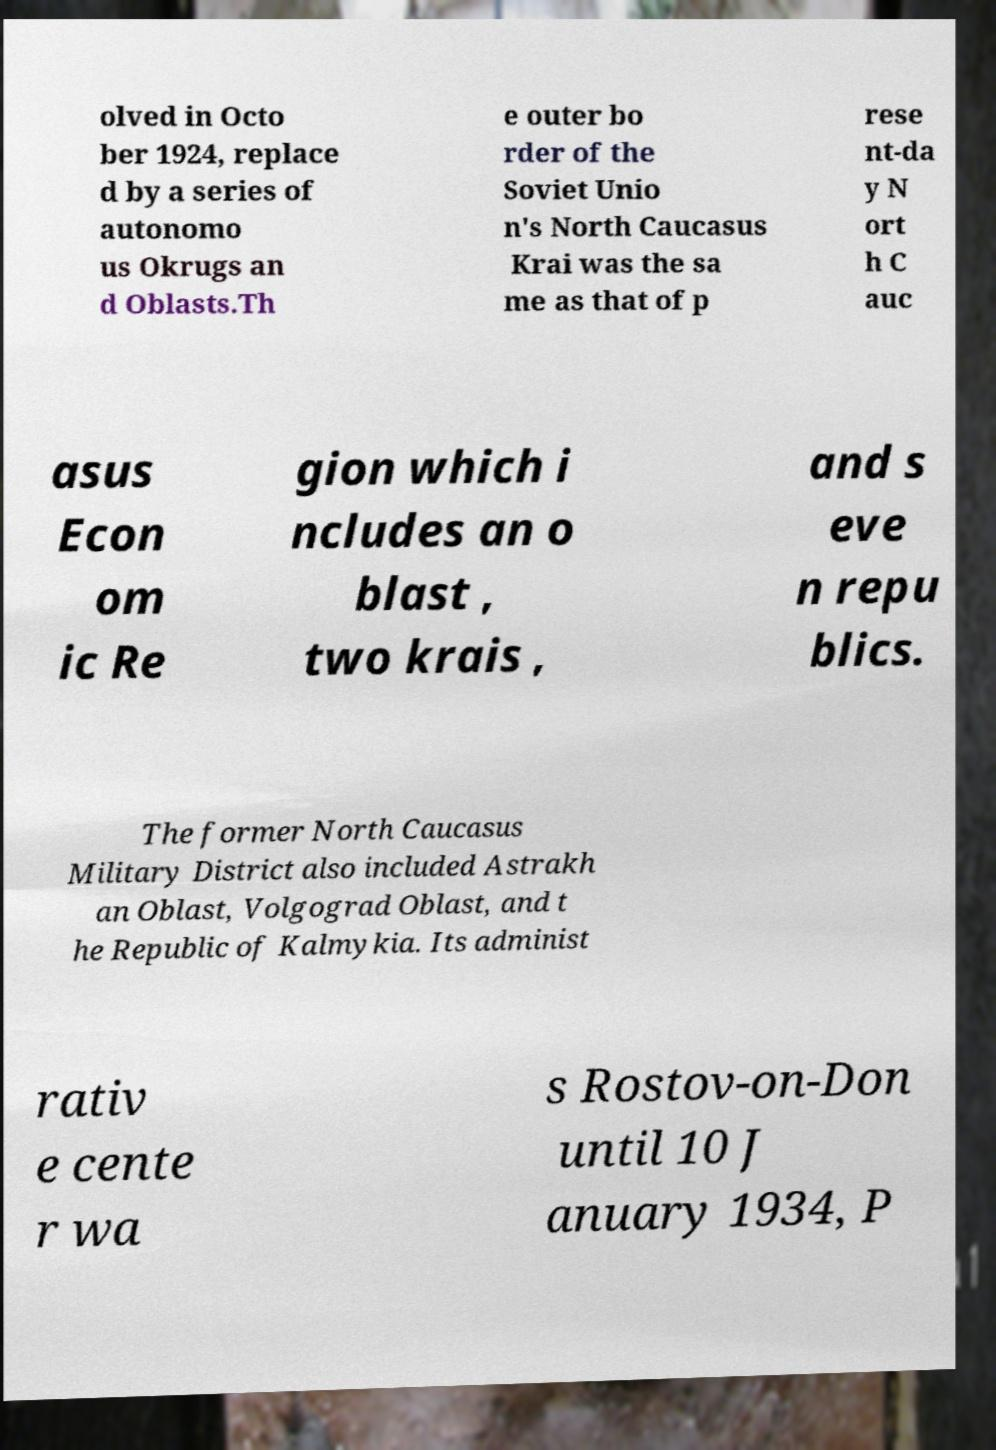Please read and relay the text visible in this image. What does it say? olved in Octo ber 1924, replace d by a series of autonomo us Okrugs an d Oblasts.Th e outer bo rder of the Soviet Unio n's North Caucasus Krai was the sa me as that of p rese nt-da y N ort h C auc asus Econ om ic Re gion which i ncludes an o blast , two krais , and s eve n repu blics. The former North Caucasus Military District also included Astrakh an Oblast, Volgograd Oblast, and t he Republic of Kalmykia. Its administ rativ e cente r wa s Rostov-on-Don until 10 J anuary 1934, P 